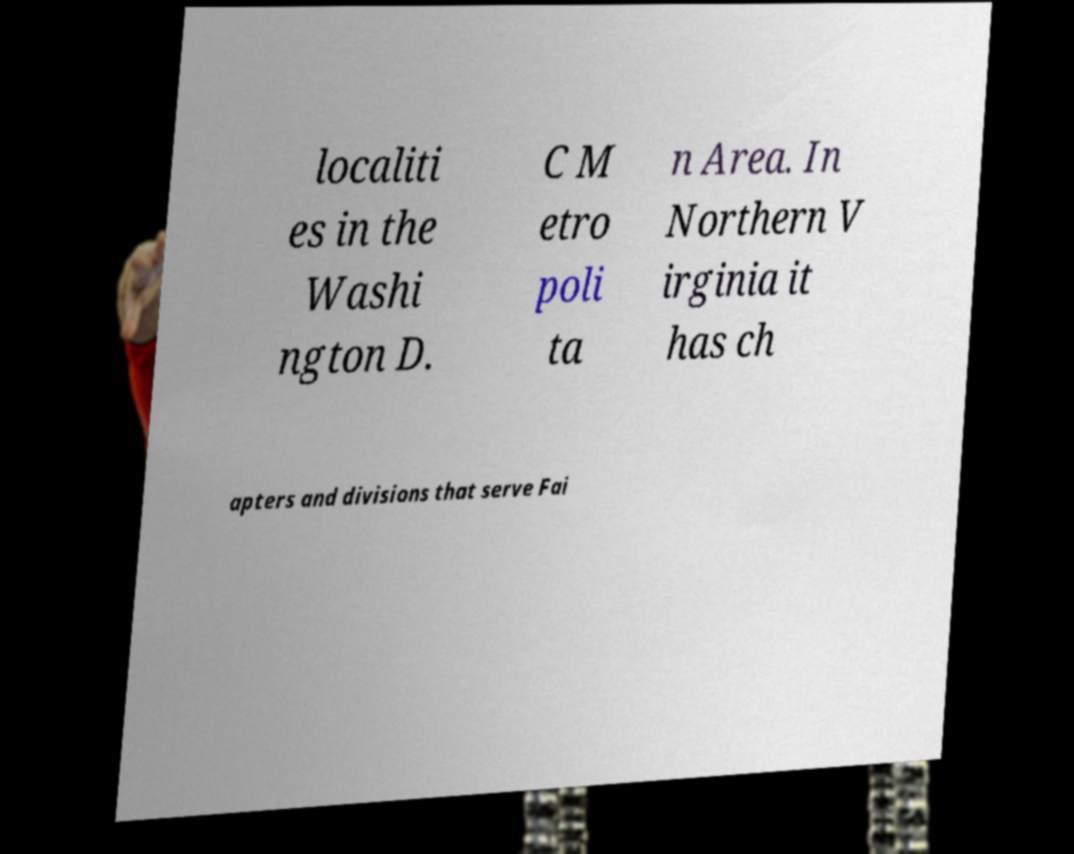Can you accurately transcribe the text from the provided image for me? localiti es in the Washi ngton D. C M etro poli ta n Area. In Northern V irginia it has ch apters and divisions that serve Fai 